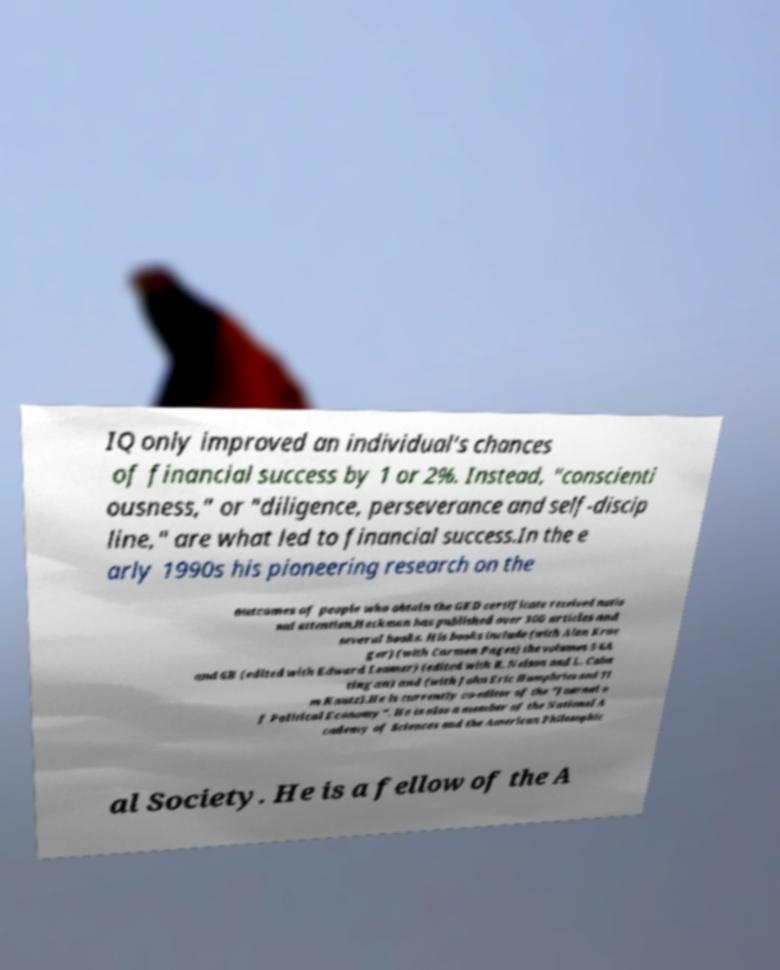Please identify and transcribe the text found in this image. IQ only improved an individual's chances of financial success by 1 or 2%. Instead, "conscienti ousness," or "diligence, perseverance and self-discip line," are what led to financial success.In the e arly 1990s his pioneering research on the outcomes of people who obtain the GED certificate received natio nal attention.Heckman has published over 300 articles and several books. His books include (with Alan Krue ger) (with Carmen Pages) the volumes 5 6A and 6B (edited with Edward Leamer) (edited with R. Nelson and L. Caba tingan) and (with John Eric Humphries and Ti m Kautz).He is currently co-editor of the "Journal o f Political Economy". He is also a member of the National A cademy of Sciences and the American Philosophic al Society. He is a fellow of the A 